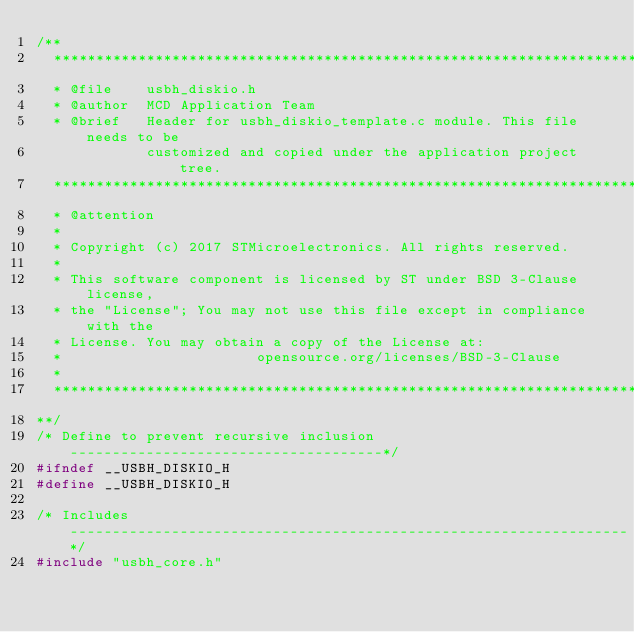<code> <loc_0><loc_0><loc_500><loc_500><_C_>/**
  ******************************************************************************
  * @file    usbh_diskio.h
  * @author  MCD Application Team
  * @brief   Header for usbh_diskio_template.c module. This file needs to be
             customized and copied under the application project tree.
  ******************************************************************************
  * @attention
  *
  * Copyright (c) 2017 STMicroelectronics. All rights reserved.
  *
  * This software component is licensed by ST under BSD 3-Clause license,
  * the "License"; You may not use this file except in compliance with the
  * License. You may obtain a copy of the License at:
  *                       opensource.org/licenses/BSD-3-Clause
  *
  ******************************************************************************
**/
/* Define to prevent recursive inclusion -------------------------------------*/
#ifndef __USBH_DISKIO_H
#define __USBH_DISKIO_H

/* Includes ------------------------------------------------------------------*/
#include "usbh_core.h"</code> 